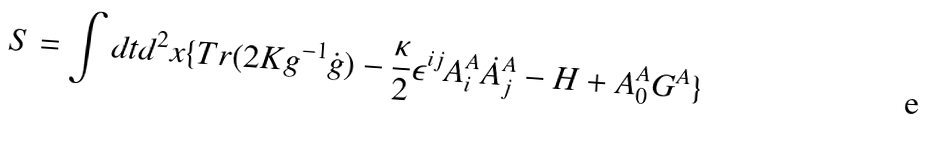Convert formula to latex. <formula><loc_0><loc_0><loc_500><loc_500>S = \int d t d ^ { 2 } x \{ T r ( 2 K g ^ { - 1 } \dot { g } ) - \frac { \kappa } { 2 } \epsilon ^ { i j } A _ { i } ^ { A } \dot { A } _ { j } ^ { A } - H + A _ { 0 } ^ { A } G ^ { A } \}</formula> 